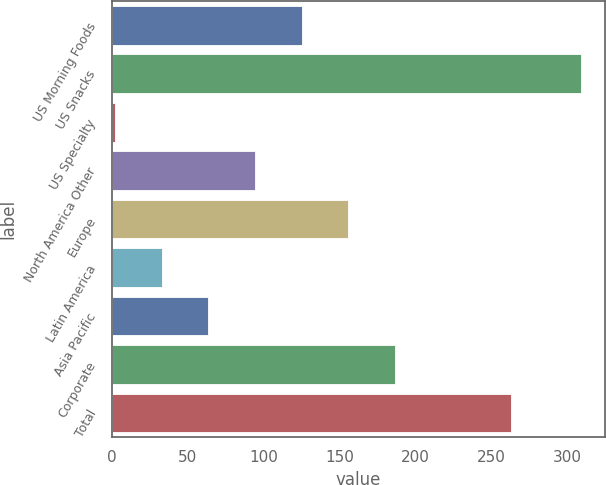Convert chart. <chart><loc_0><loc_0><loc_500><loc_500><bar_chart><fcel>US Morning Foods<fcel>US Snacks<fcel>US Specialty<fcel>North America Other<fcel>Europe<fcel>Latin America<fcel>Asia Pacific<fcel>Corporate<fcel>Total<nl><fcel>124.8<fcel>309<fcel>2<fcel>94.1<fcel>155.5<fcel>32.7<fcel>63.4<fcel>186.2<fcel>263<nl></chart> 